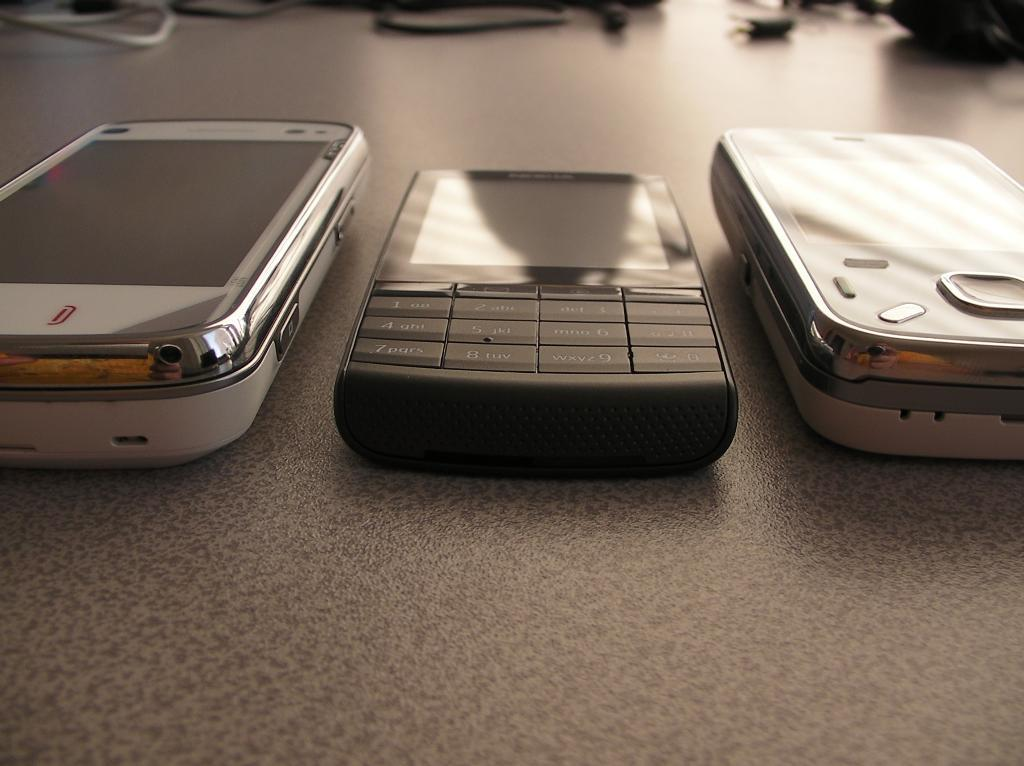What objects are in the center of the image? There are three mobile phones in the center of the image. What is located at the bottom of the image? There is a table at the bottom of the image. What can be seen in the background of the image? There are wires and some objects visible in the background of the image. What type of cow can be seen grazing in the background of the image? There is no cow present in the image; it only features mobile phones, a table, wires, and some objects in the background. 